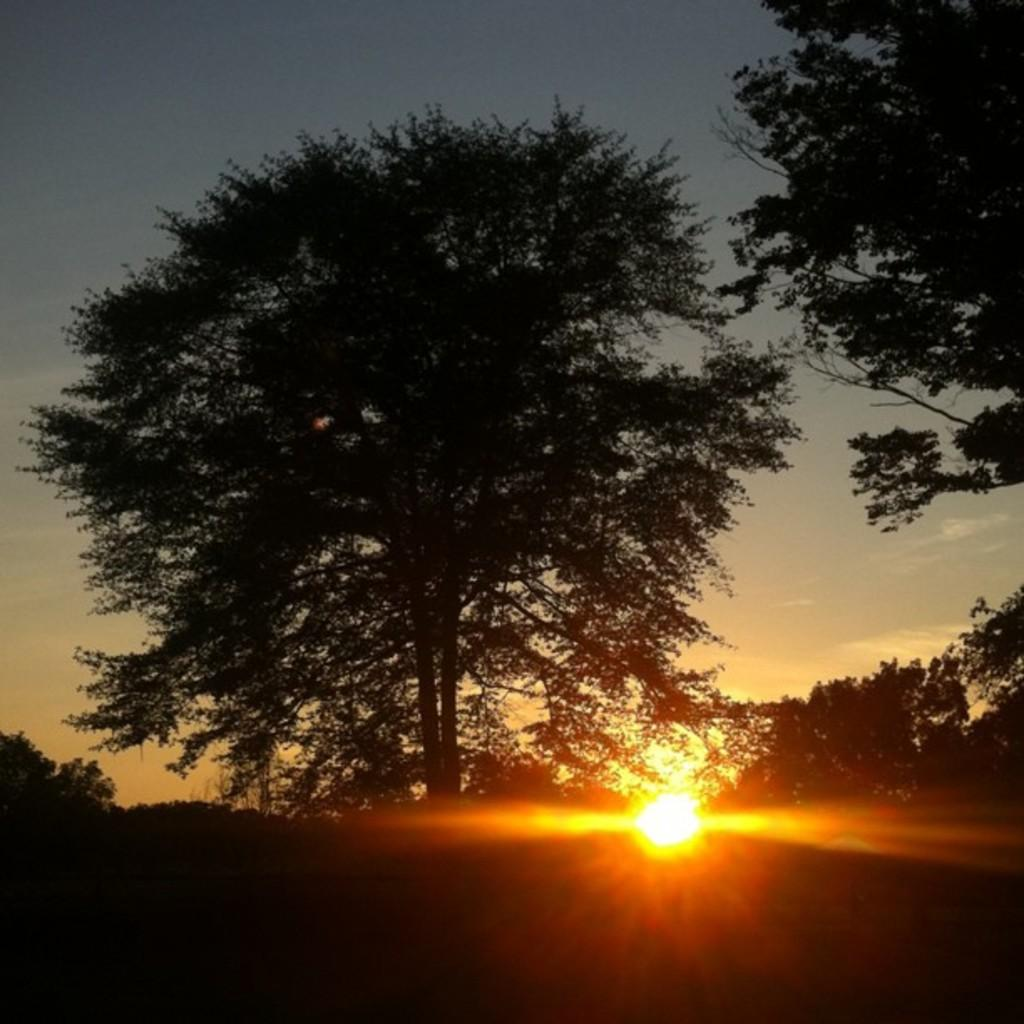What celestial body can be seen in the image? The sun is visible in the image. What else is visible in the image besides the sun? The sky is visible in the image. What color crayon is being used to draw in the image? There is no crayon or drawing present in the image; it only features the sun and the sky. 